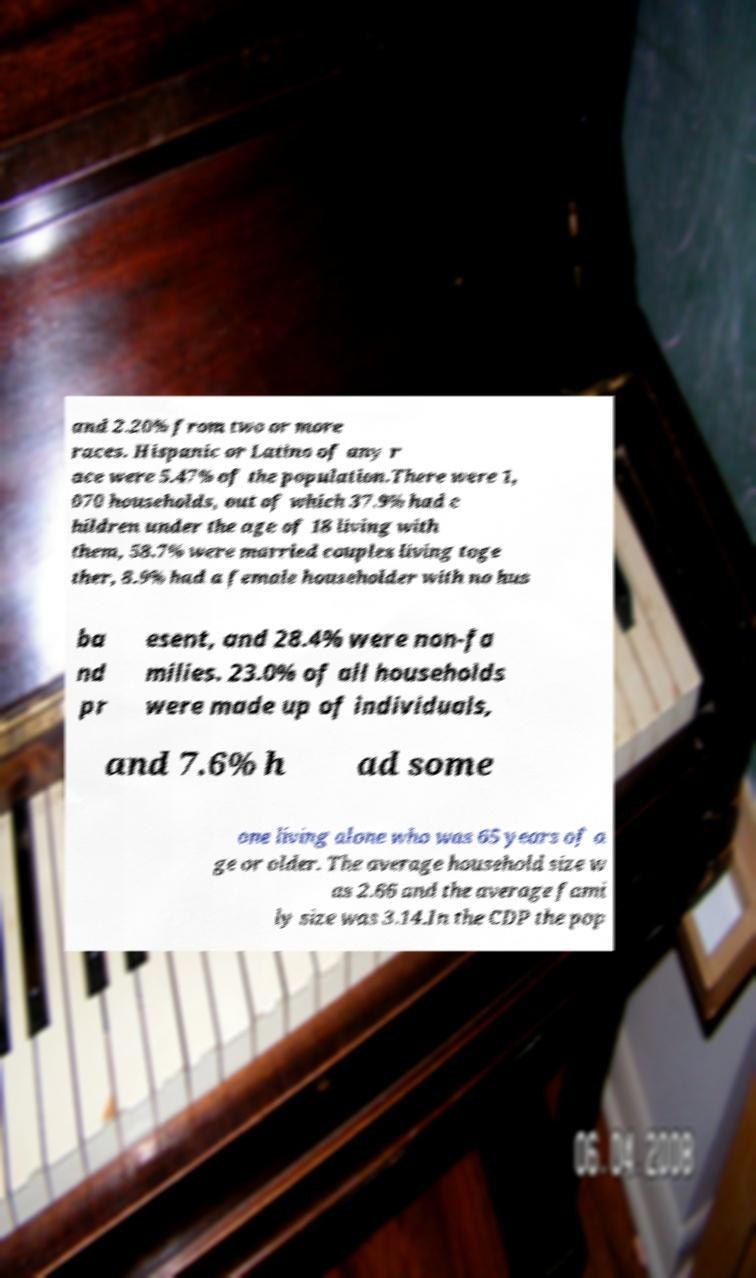Could you extract and type out the text from this image? and 2.20% from two or more races. Hispanic or Latino of any r ace were 5.47% of the population.There were 1, 070 households, out of which 37.9% had c hildren under the age of 18 living with them, 58.7% were married couples living toge ther, 8.9% had a female householder with no hus ba nd pr esent, and 28.4% were non-fa milies. 23.0% of all households were made up of individuals, and 7.6% h ad some one living alone who was 65 years of a ge or older. The average household size w as 2.66 and the average fami ly size was 3.14.In the CDP the pop 